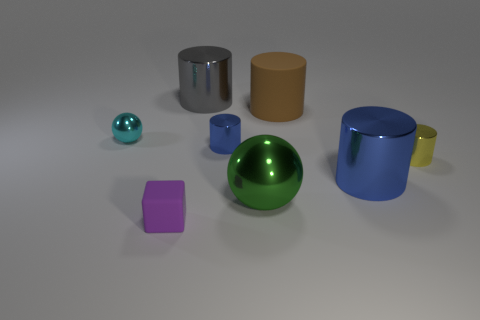There is a rubber thing that is the same shape as the small yellow metal object; what size is it?
Provide a succinct answer. Large. Is there any other thing that has the same material as the small cube?
Offer a terse response. Yes. There is a blue metal thing that is right of the matte object that is behind the green thing; what is its size?
Make the answer very short. Large. Are there the same number of big things behind the brown cylinder and tiny blue shiny objects?
Your answer should be compact. Yes. What number of other things are the same color as the big ball?
Make the answer very short. 0. Are there fewer small rubber blocks behind the rubber cube than tiny matte objects?
Provide a short and direct response. Yes. Is there a matte cylinder that has the same size as the rubber cube?
Your answer should be very brief. No. There is a large rubber cylinder; is it the same color as the big cylinder behind the brown cylinder?
Your answer should be very brief. No. What number of large green things are on the left side of the tiny shiny cylinder that is to the left of the small yellow shiny cylinder?
Your response must be concise. 0. There is a shiny ball that is in front of the metal ball left of the tiny matte thing; what color is it?
Keep it short and to the point. Green. 